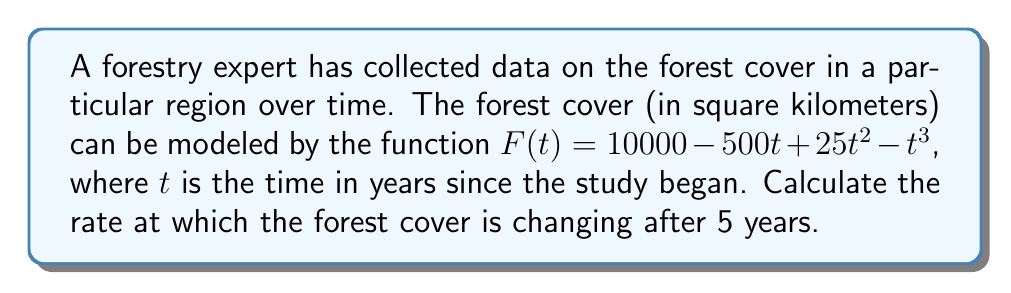Help me with this question. To solve this problem, we need to find the rate of change of the forest cover function at $t = 5$ years. This rate of change is given by the derivative of the function $F(t)$ evaluated at $t = 5$.

Let's follow these steps:

1) First, we need to find the derivative of $F(t)$. 
   
   $F(t) = 10000 - 500t + 25t^2 - t^3$
   
   $F'(t) = -500 + 50t - 3t^2$

2) Now that we have the derivative, which represents the instantaneous rate of change, we need to evaluate it at $t = 5$.

   $F'(5) = -500 + 50(5) - 3(5)^2$
   
   $= -500 + 250 - 3(25)$
   
   $= -500 + 250 - 75$
   
   $= -325$

3) Interpret the result: The negative value indicates that the forest cover is decreasing. The rate of change is 325 square kilometers per year at $t = 5$ years.
Answer: The rate at which the forest cover is changing after 5 years is $-325$ square kilometers per year. 